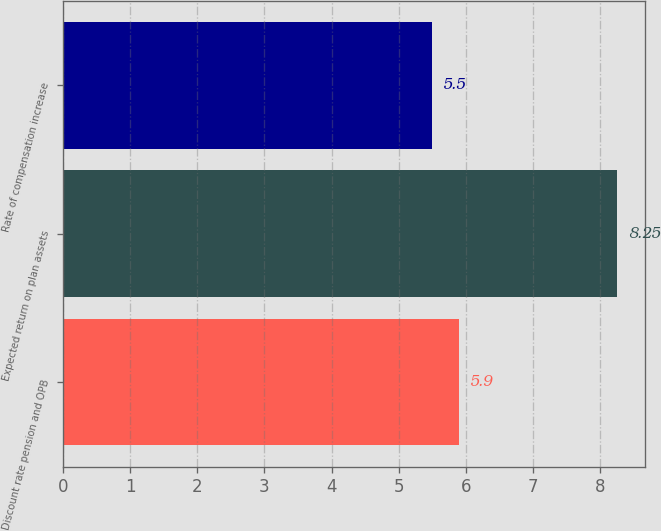<chart> <loc_0><loc_0><loc_500><loc_500><bar_chart><fcel>Discount rate pension and OPB<fcel>Expected return on plan assets<fcel>Rate of compensation increase<nl><fcel>5.9<fcel>8.25<fcel>5.5<nl></chart> 